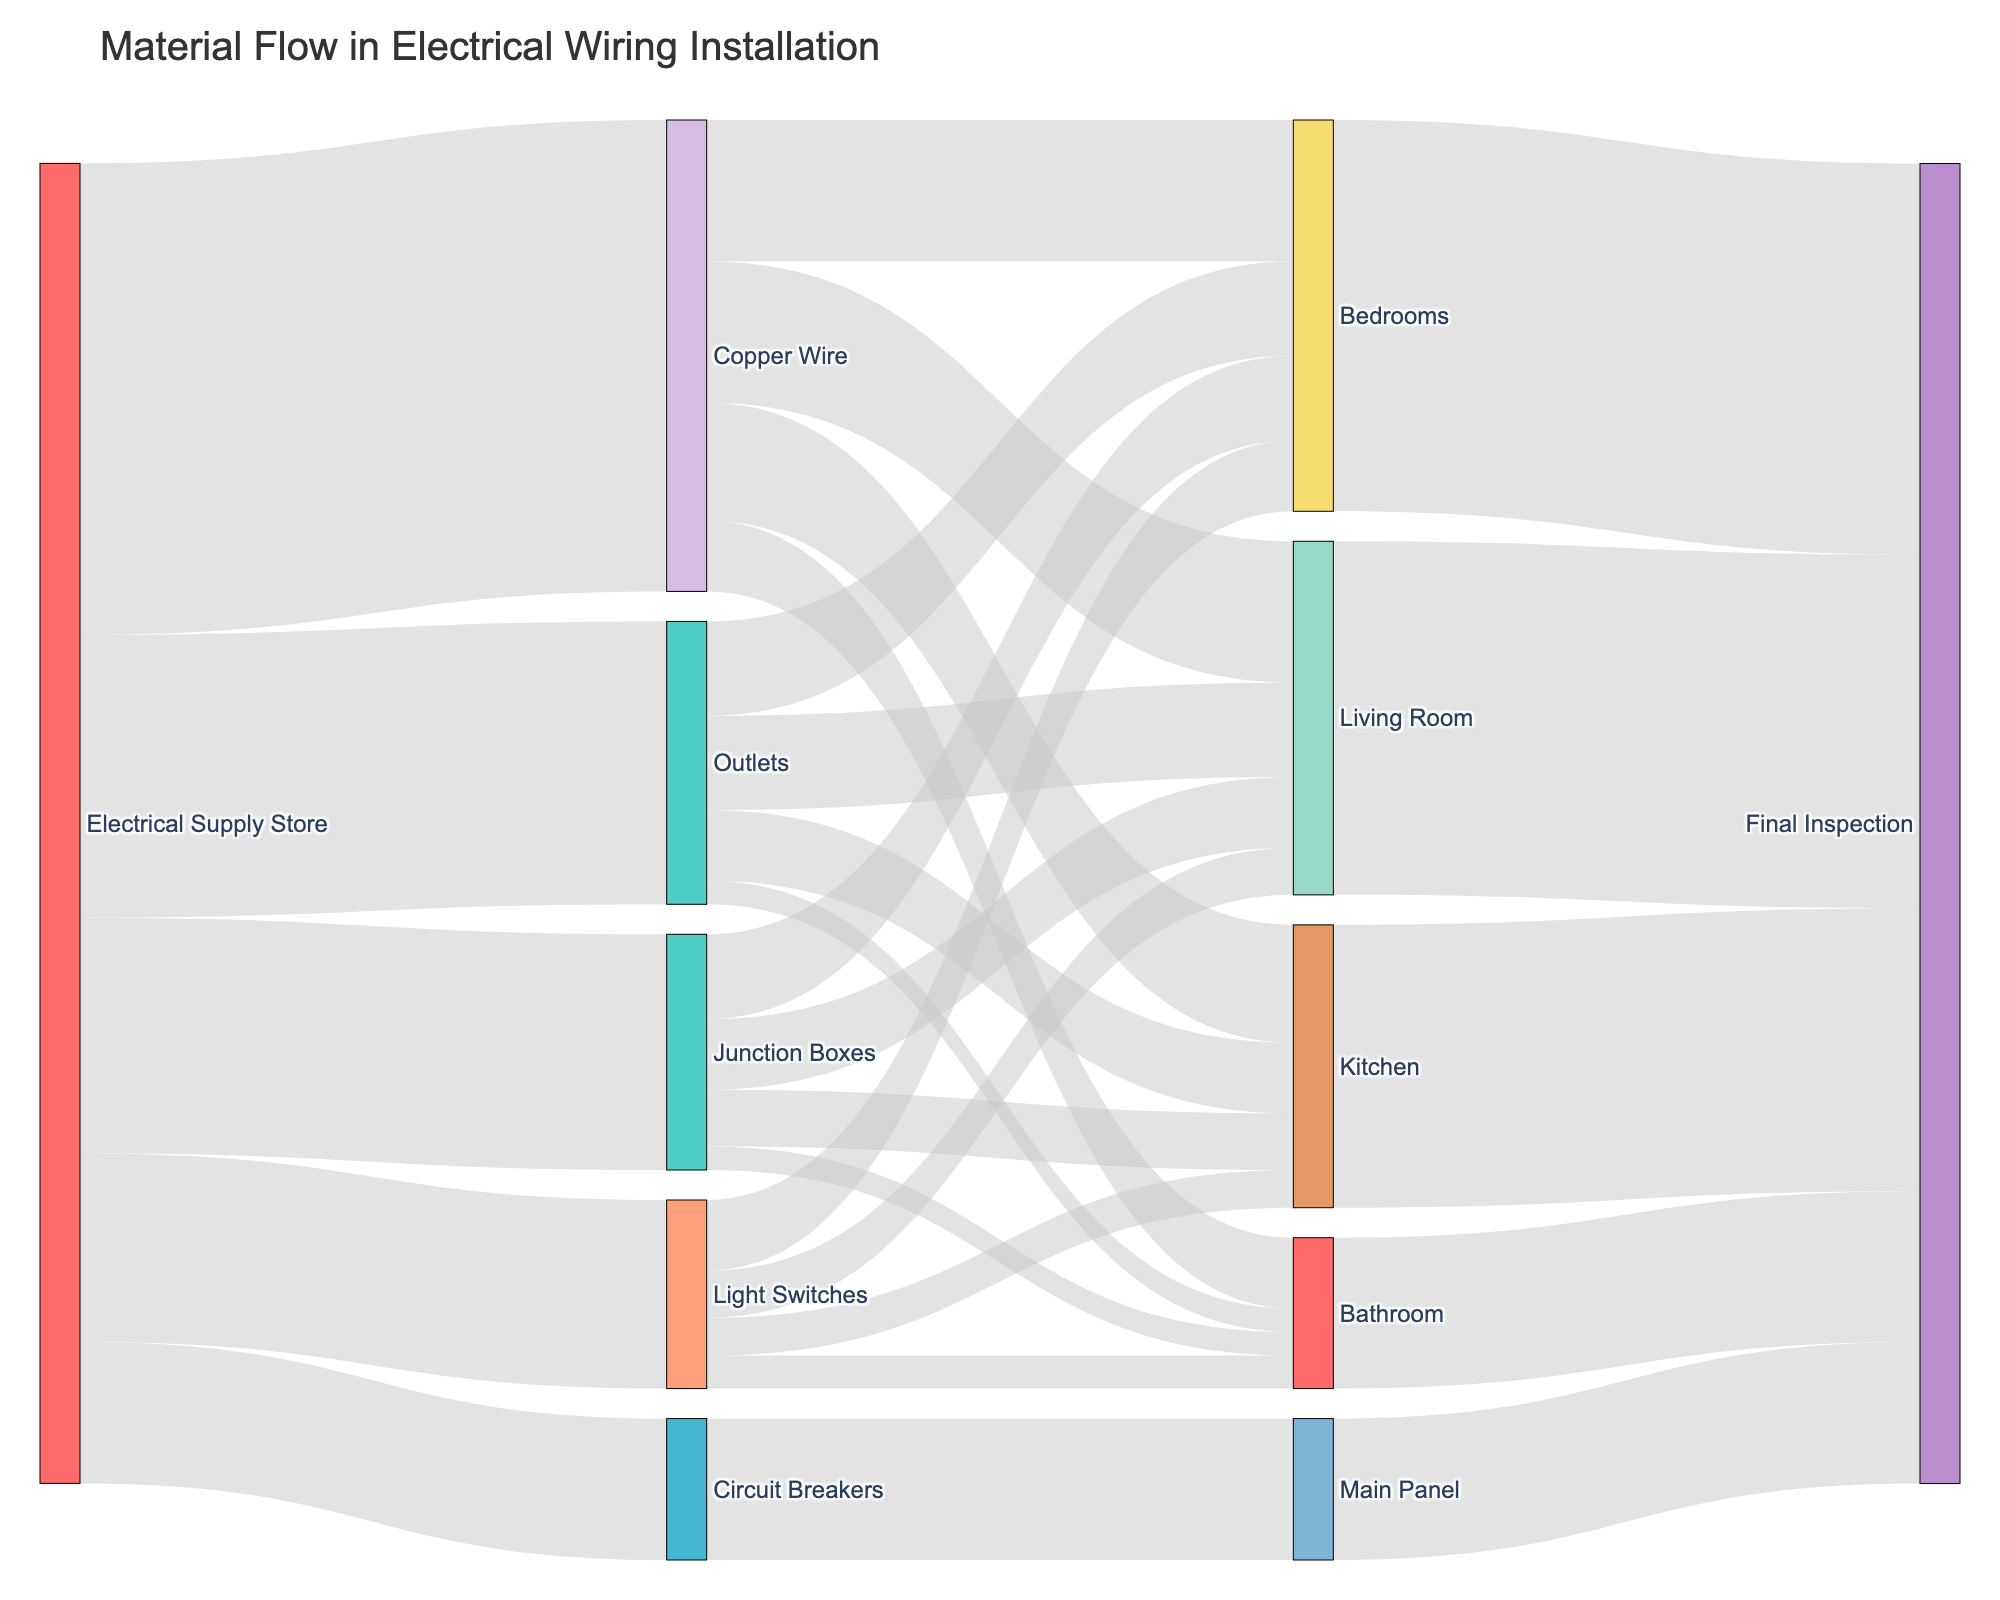What is the total amount of Copper Wire used in the Living Room? The diagram shows that 30 units of Copper Wire flow into the Living Room.
Answer: 30 Which room uses the most Junction Boxes? From the diagram, the Bedrooms use 18 units of Junction Boxes, which is the highest compared to other rooms.
Answer: Bedrooms How much Copper Wire is used in the Kitchen and Bathroom combined? The Kitchen uses 25 units of Copper Wire and the Bathroom uses 15 units. Adding these together, 25 + 15 = 40 units.
Answer: 40 Which material flows directly into the Main Panel? The Sankey diagram shows that Circuit Breakers flow into the Main Panel with a value of 30 units.
Answer: Circuit Breakers What is the total flow of materials from the Electrical Supply Store to the various targets? Summing up all the values from the Electrical Supply Store: 100 (Copper Wire) + 50 (Junction Boxes) + 30 (Circuit Breakers) + 40 (Light Switches) + 60 (Outlets) = 280 units.
Answer: 280 Compare the amount of Outlets used in the Bedrooms and Kitchen. Bedrooms use 20 units of Outlets while the Kitchen uses 15 units. Bedrooms have a higher usage.
Answer: Bedrooms How many total units flow into the Final Inspection from all sources? Adding the values from Living Room (75), Kitchen (60), Bedrooms (83), Bathroom (32), and Main Panel (30): 75 + 60 + 83 + 32 + 30 = 280 units.
Answer: 280 Which material from the Electrical Supply Store has the smallest total flow? The diagram shows that Circuit Breakers have the smallest flow with 30 units.
Answer: Circuit Breakers Calculate the total amount of Light Switches used across all rooms. Adding Light Switches used in Living Room (10), Kitchen (8), Bedrooms (15), and Bathroom (7): 10 + 8 + 15 + 7 = 40 units.
Answer: 40 